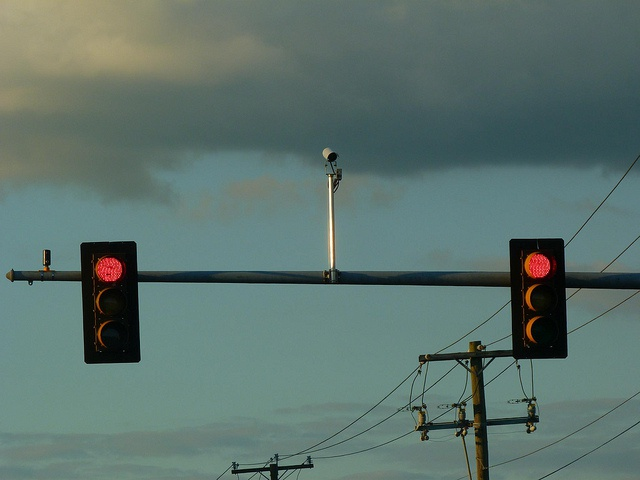Describe the objects in this image and their specific colors. I can see traffic light in tan, black, teal, red, and maroon tones and traffic light in tan, black, maroon, brown, and teal tones in this image. 